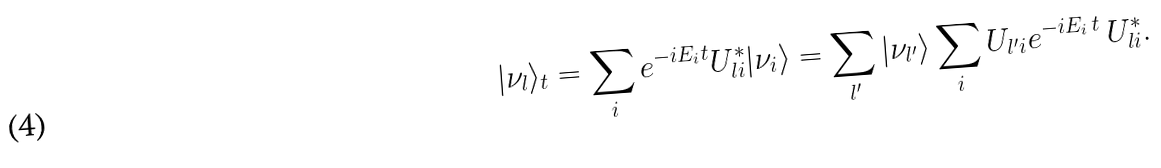Convert formula to latex. <formula><loc_0><loc_0><loc_500><loc_500>| \nu _ { l } \rangle _ { t } = \sum _ { i } e ^ { - i E _ { i } t } U _ { l i } ^ { * } | \nu _ { i } \rangle = \sum _ { l ^ { \prime } } | \nu _ { l ^ { \prime } } \rangle \sum _ { i } U _ { l ^ { \prime } i } e ^ { - i E _ { i } \, t } \, U _ { l i } ^ { * } .</formula> 